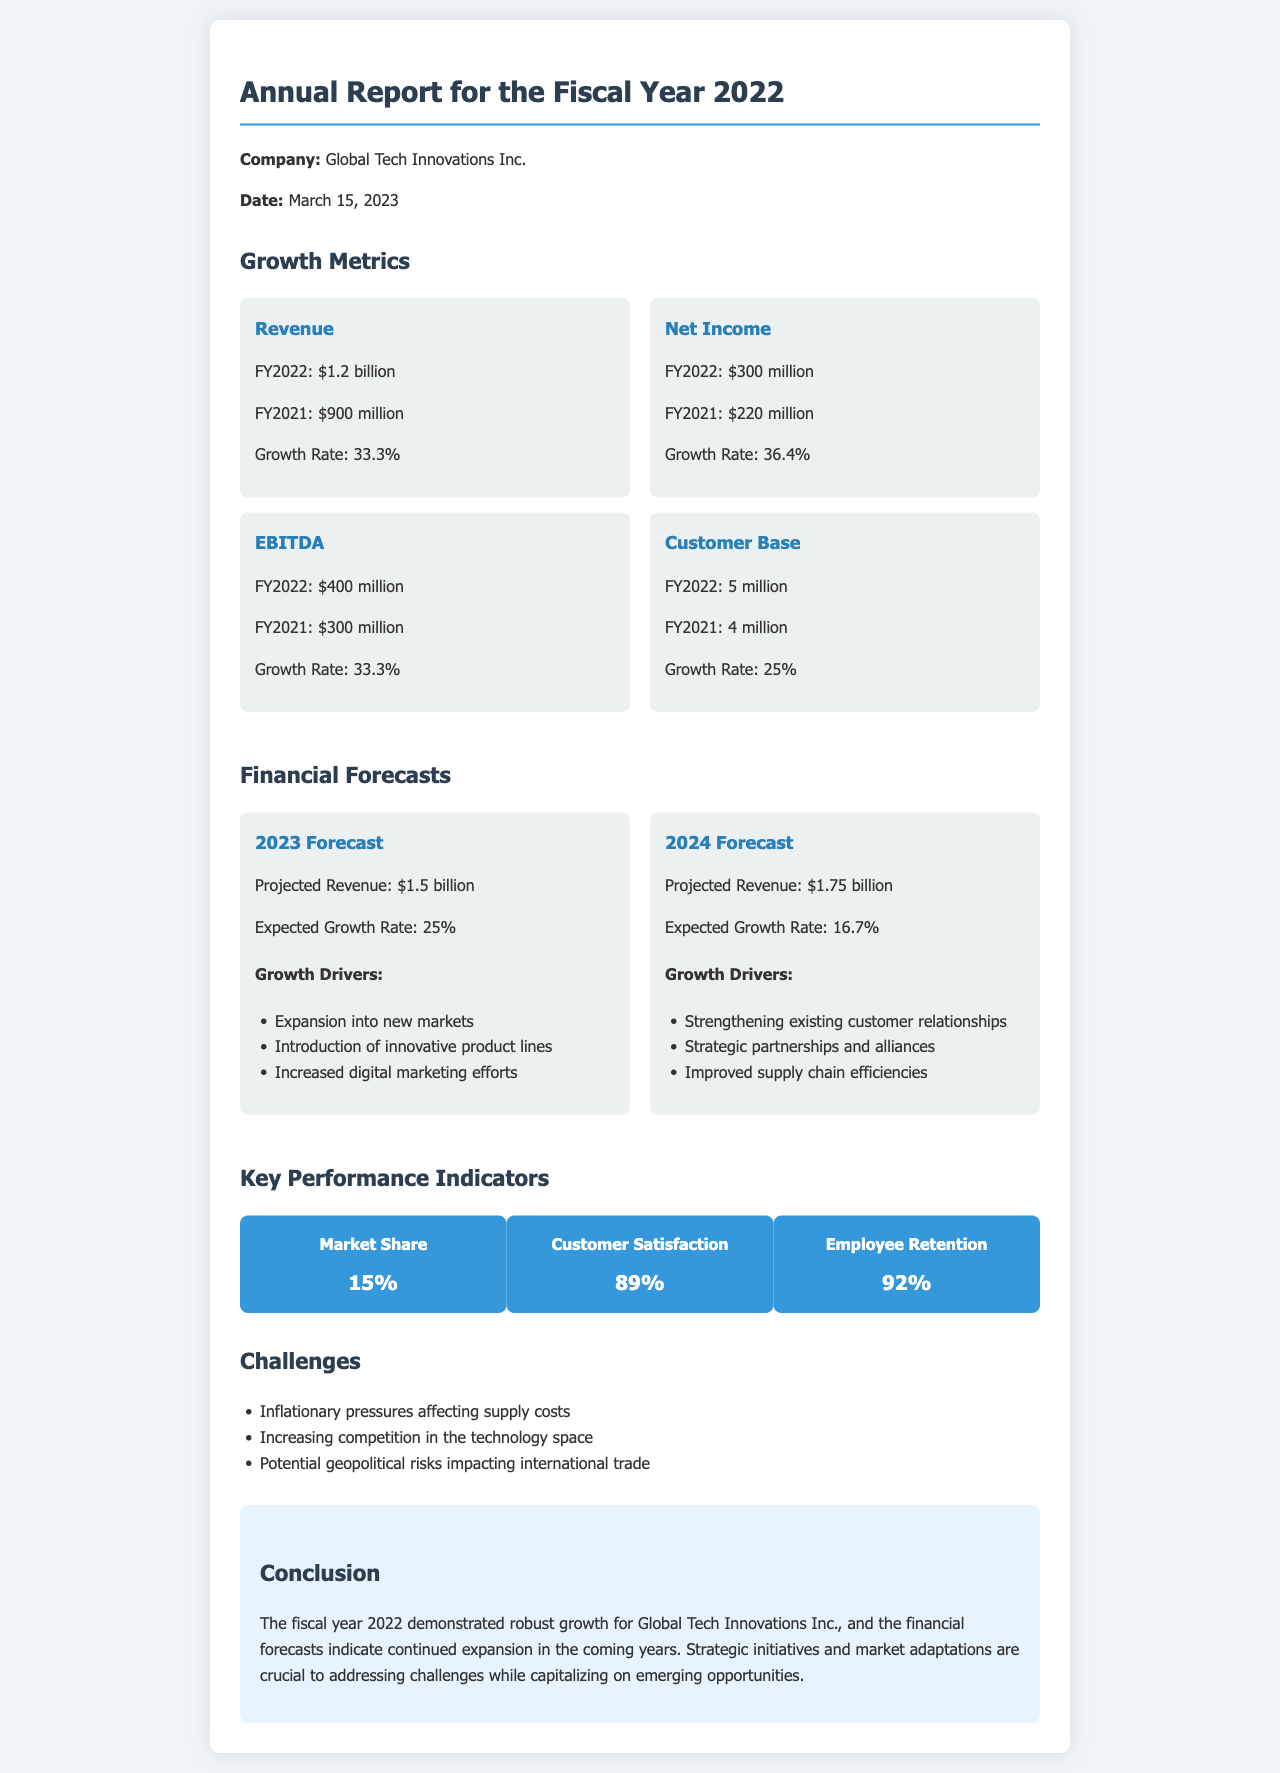what was the revenue for FY2022? The document states that the revenue for FY2022 was $1.2 billion.
Answer: $1.2 billion what was the net income growth rate? The growth rate for net income is provided as 36.4%.
Answer: 36.4% how many customers did the company have in FY2022? The report indicates that the customer base for FY2022 was 5 million.
Answer: 5 million what is the projected revenue for 2023? According to the financial forecasts, the projected revenue for 2023 is $1.5 billion.
Answer: $1.5 billion which factor is listed as a growth driver for 2024? The document lists "Strategic partnerships and alliances" as one of the growth drivers for 2024.
Answer: Strategic partnerships and alliances what is the company's market share? The market share of the company is stated to be 15%.
Answer: 15% what percentage of customer satisfaction is reported? The report shows that customer satisfaction stands at 89%.
Answer: 89% what is one of the challenges mentioned? One of the challenges mentioned is "Inflationary pressures affecting supply costs."
Answer: Inflationary pressures affecting supply costs what is the total EBITDA for FY2022? The total EBITDA reported for FY2022 is $400 million.
Answer: $400 million 